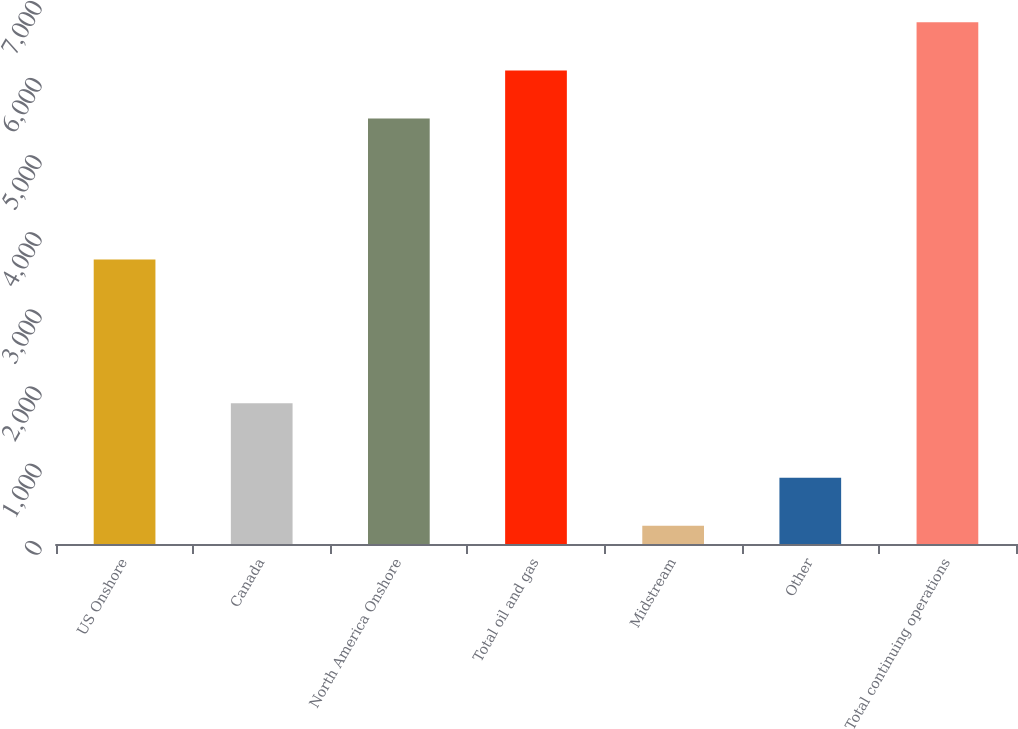Convert chart. <chart><loc_0><loc_0><loc_500><loc_500><bar_chart><fcel>US Onshore<fcel>Canada<fcel>North America Onshore<fcel>Total oil and gas<fcel>Midstream<fcel>Other<fcel>Total continuing operations<nl><fcel>3689<fcel>1826<fcel>5515<fcel>6139<fcel>236<fcel>860<fcel>6763<nl></chart> 